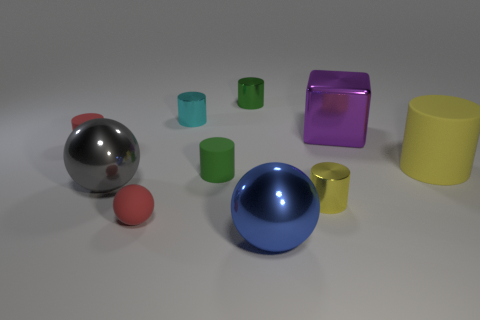What can the different colors and shapes in this image suggest about its purpose? The varied colors and geometric shapes of the objects, including cylinders, spheres, and a cube, are reminiscent of a test scene used in 3D modeling and rendering. Their arrangement and differences in size and color could be aimed at demonstrating shading, reflections, and texture mapping capabilities of a rendering engine or to calibrate color and contrast settings on a display. 